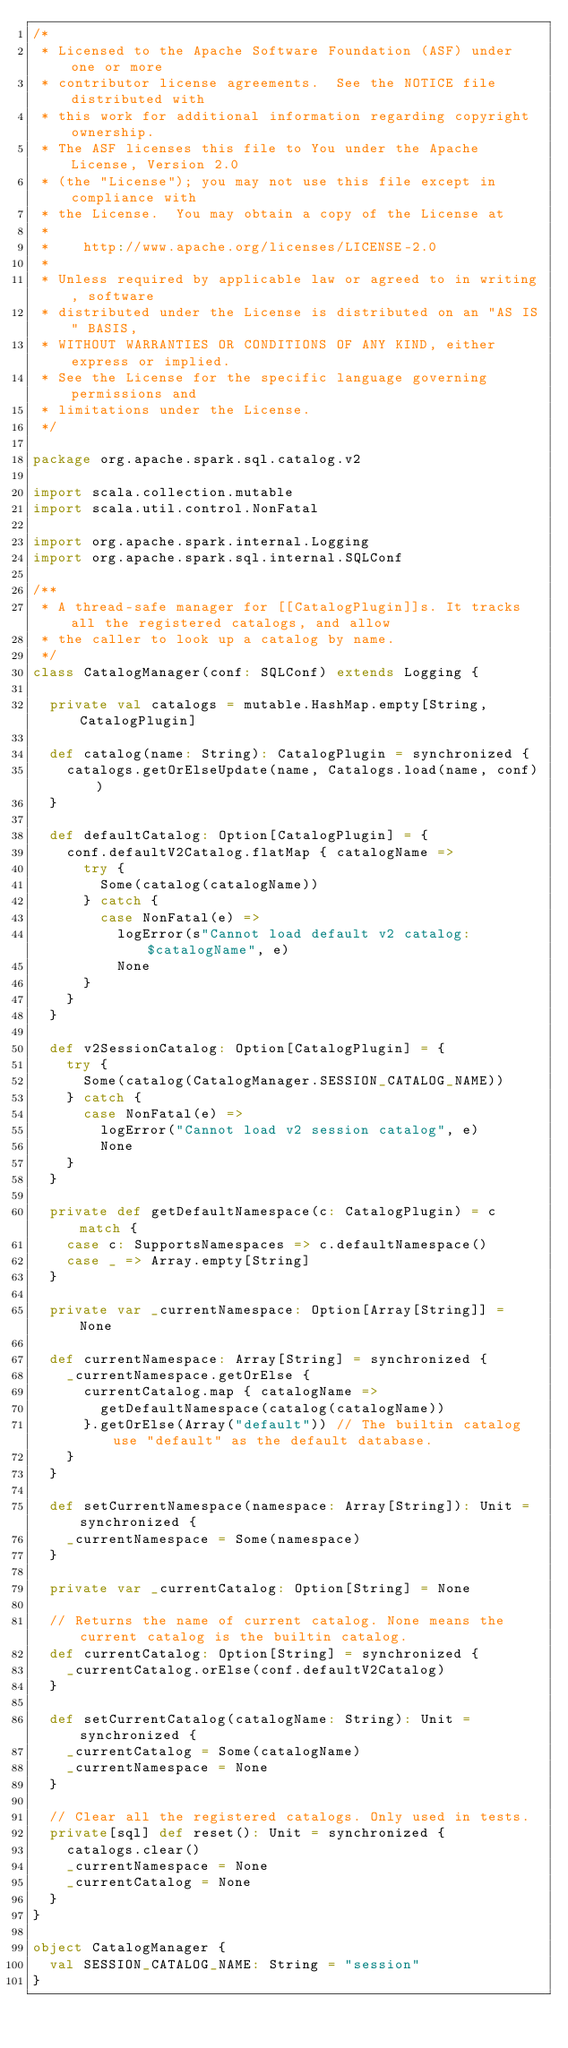Convert code to text. <code><loc_0><loc_0><loc_500><loc_500><_Scala_>/*
 * Licensed to the Apache Software Foundation (ASF) under one or more
 * contributor license agreements.  See the NOTICE file distributed with
 * this work for additional information regarding copyright ownership.
 * The ASF licenses this file to You under the Apache License, Version 2.0
 * (the "License"); you may not use this file except in compliance with
 * the License.  You may obtain a copy of the License at
 *
 *    http://www.apache.org/licenses/LICENSE-2.0
 *
 * Unless required by applicable law or agreed to in writing, software
 * distributed under the License is distributed on an "AS IS" BASIS,
 * WITHOUT WARRANTIES OR CONDITIONS OF ANY KIND, either express or implied.
 * See the License for the specific language governing permissions and
 * limitations under the License.
 */

package org.apache.spark.sql.catalog.v2

import scala.collection.mutable
import scala.util.control.NonFatal

import org.apache.spark.internal.Logging
import org.apache.spark.sql.internal.SQLConf

/**
 * A thread-safe manager for [[CatalogPlugin]]s. It tracks all the registered catalogs, and allow
 * the caller to look up a catalog by name.
 */
class CatalogManager(conf: SQLConf) extends Logging {

  private val catalogs = mutable.HashMap.empty[String, CatalogPlugin]

  def catalog(name: String): CatalogPlugin = synchronized {
    catalogs.getOrElseUpdate(name, Catalogs.load(name, conf))
  }

  def defaultCatalog: Option[CatalogPlugin] = {
    conf.defaultV2Catalog.flatMap { catalogName =>
      try {
        Some(catalog(catalogName))
      } catch {
        case NonFatal(e) =>
          logError(s"Cannot load default v2 catalog: $catalogName", e)
          None
      }
    }
  }

  def v2SessionCatalog: Option[CatalogPlugin] = {
    try {
      Some(catalog(CatalogManager.SESSION_CATALOG_NAME))
    } catch {
      case NonFatal(e) =>
        logError("Cannot load v2 session catalog", e)
        None
    }
  }

  private def getDefaultNamespace(c: CatalogPlugin) = c match {
    case c: SupportsNamespaces => c.defaultNamespace()
    case _ => Array.empty[String]
  }

  private var _currentNamespace: Option[Array[String]] = None

  def currentNamespace: Array[String] = synchronized {
    _currentNamespace.getOrElse {
      currentCatalog.map { catalogName =>
        getDefaultNamespace(catalog(catalogName))
      }.getOrElse(Array("default")) // The builtin catalog use "default" as the default database.
    }
  }

  def setCurrentNamespace(namespace: Array[String]): Unit = synchronized {
    _currentNamespace = Some(namespace)
  }

  private var _currentCatalog: Option[String] = None

  // Returns the name of current catalog. None means the current catalog is the builtin catalog.
  def currentCatalog: Option[String] = synchronized {
    _currentCatalog.orElse(conf.defaultV2Catalog)
  }

  def setCurrentCatalog(catalogName: String): Unit = synchronized {
    _currentCatalog = Some(catalogName)
    _currentNamespace = None
  }

  // Clear all the registered catalogs. Only used in tests.
  private[sql] def reset(): Unit = synchronized {
    catalogs.clear()
    _currentNamespace = None
    _currentCatalog = None
  }
}

object CatalogManager {
  val SESSION_CATALOG_NAME: String = "session"
}
</code> 